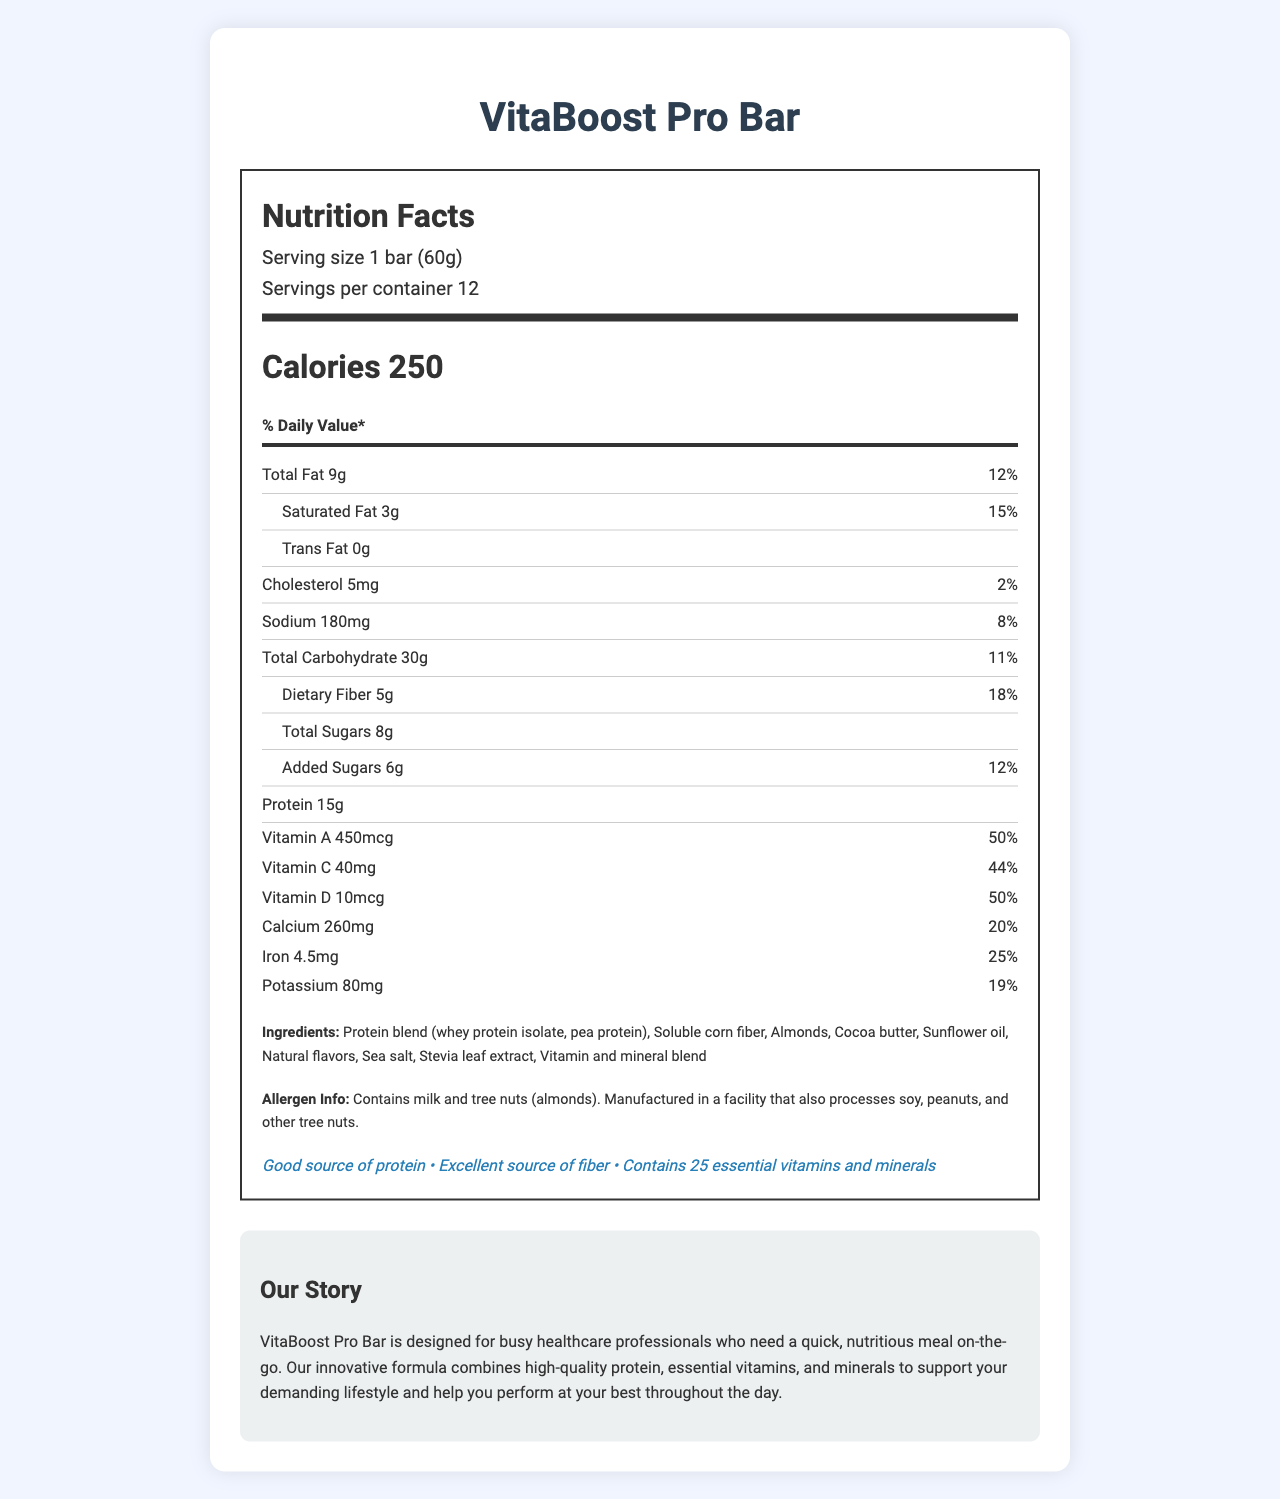what is the serving size of the VitaBoost Pro Bar? The serving size is clearly stated at the beginning of the document as "1 bar (60g)".
Answer: 1 bar (60g) how many servings are there per container? The document indicates that there are 12 servings per container.
Answer: 12 how much protein does one serving of the VitaBoost Pro Bar provide? The protein content per serving is listed as "15g" in the Nutrition Facts section.
Answer: 15g what is the percentage daily value of Vitamin B12 provided by the bar? The daily value percentage for Vitamin B12 is specified as "100%" in the list of vitamins and minerals.
Answer: 100% how many total carbohydrates does one bar contain? The total carbohydrate content is given as "30g" for one bar.
Answer: 30g which ingredient is listed first in the ingredients list? A. Almonds B. Soluble corn fiber C. Protein blend D. Sea salt The first ingredient listed is "Protein blend (whey protein isolate, pea protein)".
Answer: C what is the percentage daily value of saturated fat per serving? A. 10% B. 15% C. 20% D. 25% The percentage daily value of saturated fat is listed as "15%".
Answer: B does the bar contain any trans fat? The amount of trans fat is listed as "0g", indicating that the bar does not contain trans fat.
Answer: No is this product suitable for someone with a tree nut allergy? The allergen information states that the product contains tree nuts (almonds).
Answer: No how many vitamins and minerals does the VitaBoost Pro Bar contain? In the health claims section, it is mentioned that the bar contains "25 essential vitamins and minerals".
Answer: 25 provide a summary of the entire document The document includes the product name, serving size, number of servings per container, and a comprehensive breakdown of the nutritional content per serving. It lists total fats, carbohydrates, proteins, vitamins, and minerals, along with daily value percentages. Ingredients and allergen information are provided, followed by health claims such as being a good source of protein and fiber. The brand story highlights the product's target audience and its formulation to support a busy lifestyle.
Answer: The document is a nutrition facts label for the VitaBoost Pro Bar, a vitamin-fortified meal replacement bar designed for busy healthcare professionals. The label details the nutritional content per serving, ingredients, allergen information, health claims, and a brand story emphasizing the bar's benefits for a demanding lifestyle. what is the main source of protein in the bar? The ingredient list reveals that the main source of protein is a protein blend consisting of whey protein isolate and pea protein.
Answer: Protein blend (whey protein isolate, pea protein) what is the daily value percentage of calcium per serving? The document lists the daily value percentage for calcium as "20%" per serving.
Answer: 20% are there any artificial sweeteners in the VitaBoost Pro Bar? The document mentions "Stevia leaf extract" as a sweetener but does not provide information about other potential artificial sweeteners, leaving the question partially unanswered.
Answer: Not enough information what is the total fat content of the product? The total fat content is clearly listed as "9g" in the Nutrition Facts section.
Answer: 9g how much dietary fiber is provided per serving? The dietary fiber content per serving is specified as "5g".
Answer: 5g which mineral provides the highest daily value percentage? A. Calcium B. Iron C. Zinc D. Biotin Biotin provides the highest daily value percentage listed in the document at "500%".
Answer: D 